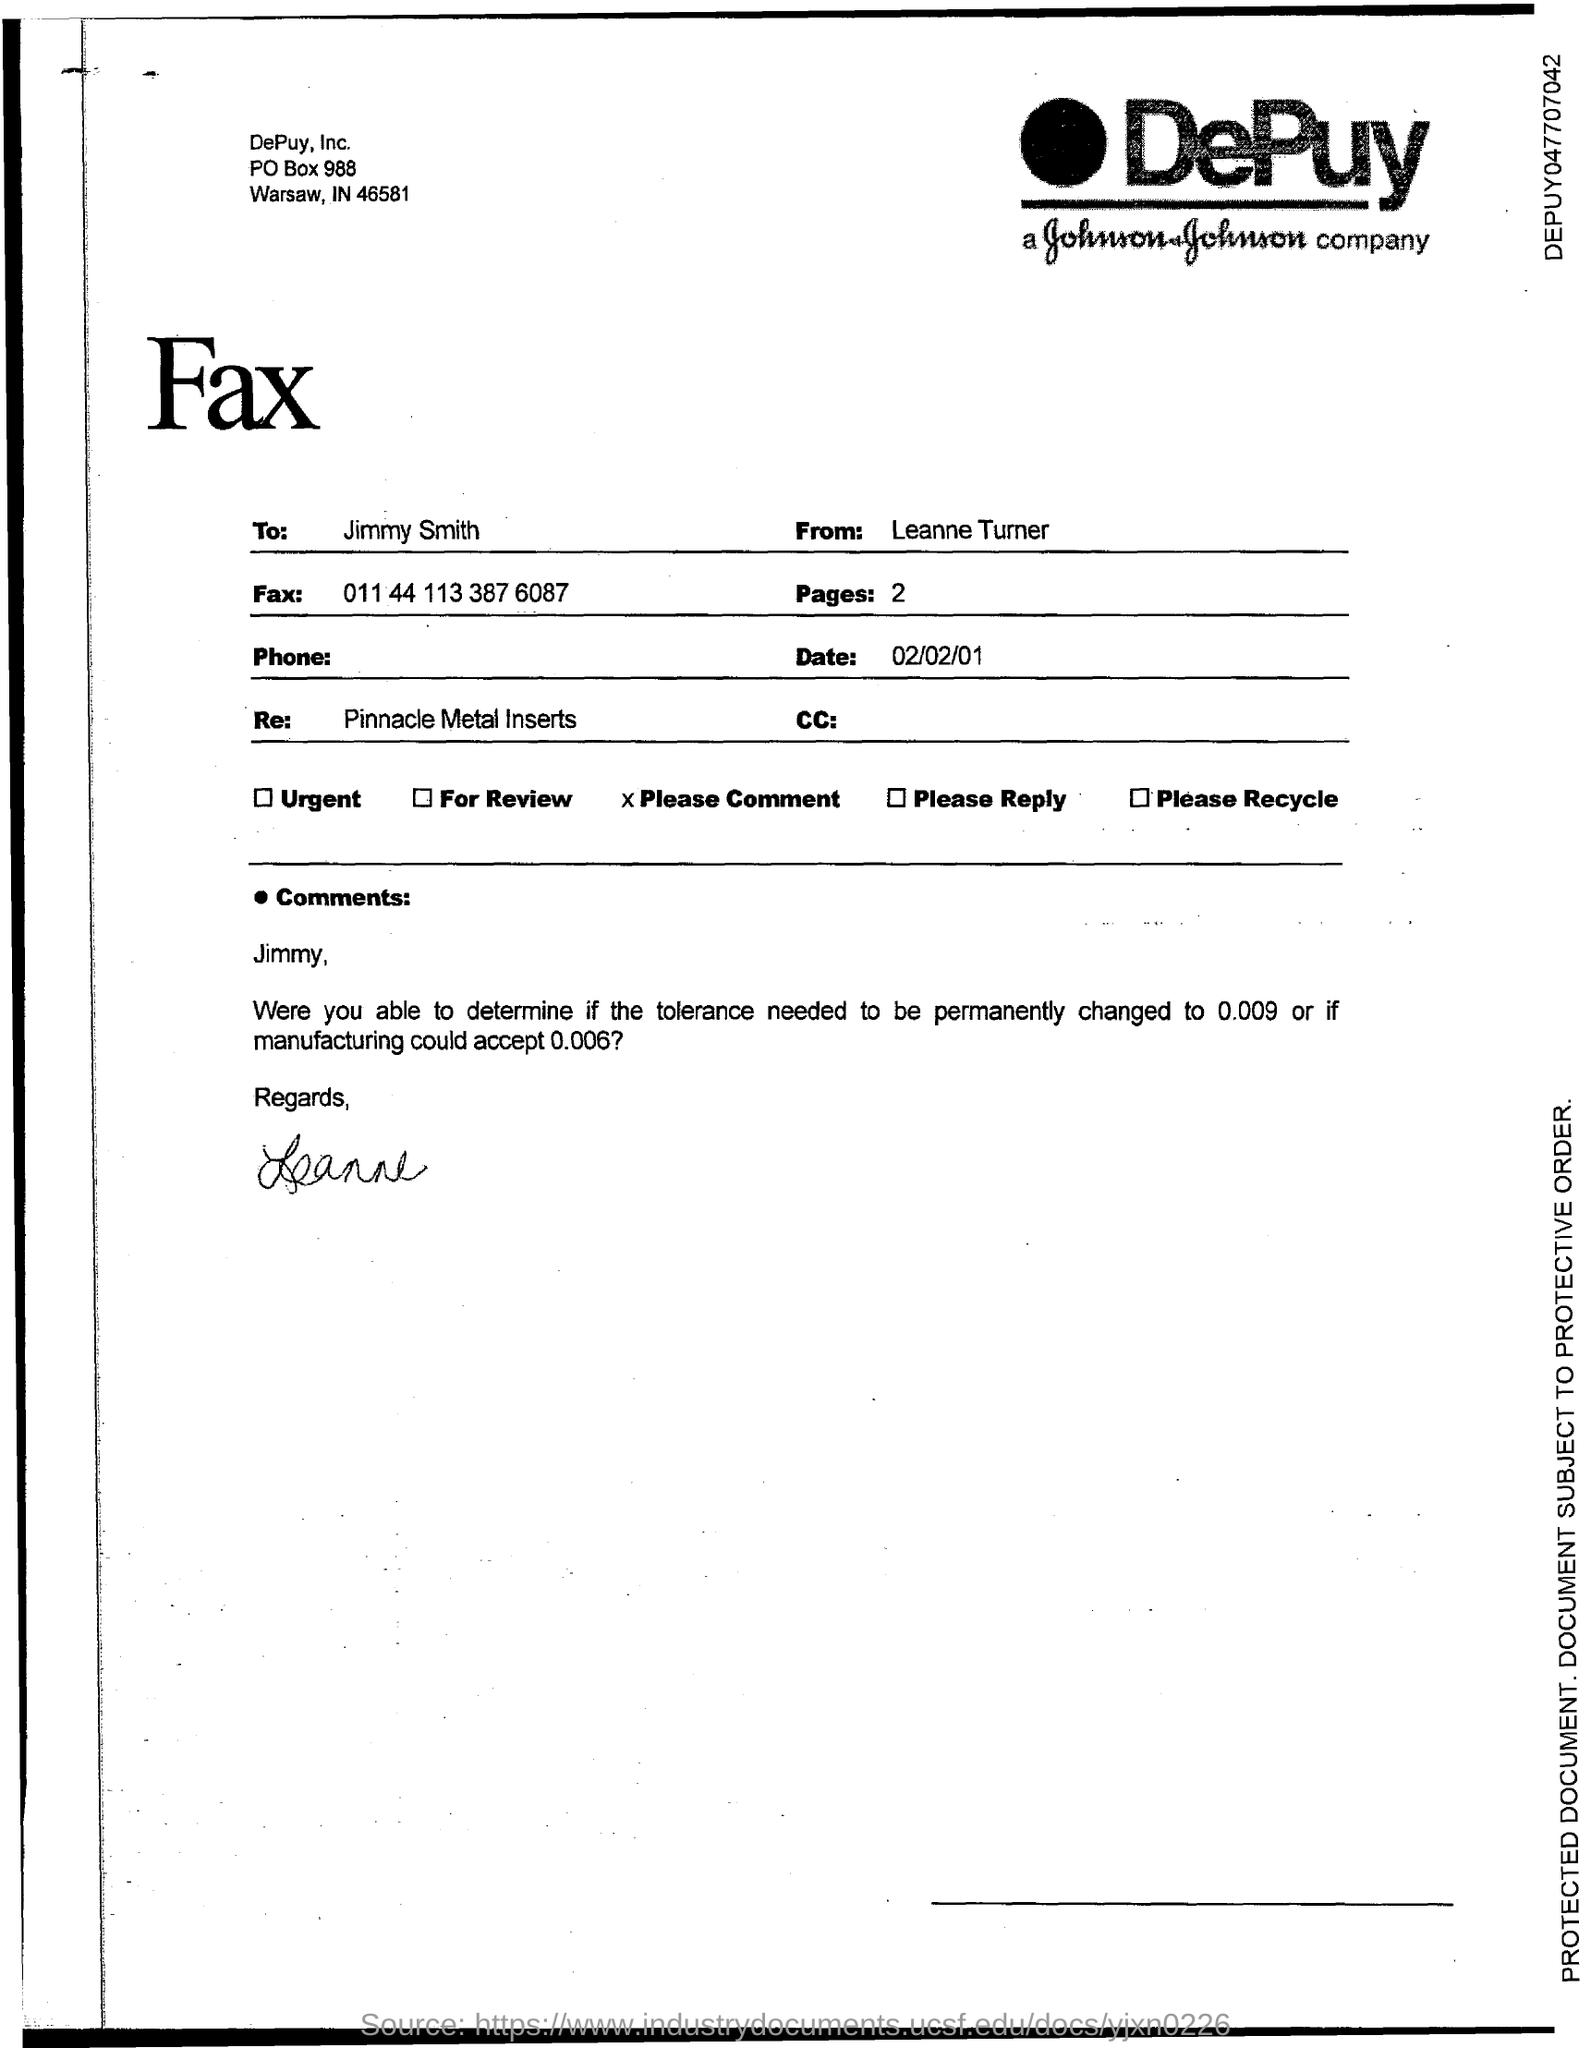Highlight a few significant elements in this photo. The fax number is 011 44 113 387 6087. What is the number of pages? It is two or more. The address of DePuy, Inc. is a PO Box number of 988. DePuy, Inc. is located in the state of Indiana. 